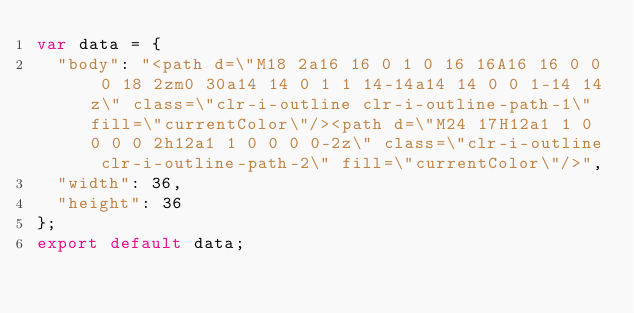Convert code to text. <code><loc_0><loc_0><loc_500><loc_500><_JavaScript_>var data = {
	"body": "<path d=\"M18 2a16 16 0 1 0 16 16A16 16 0 0 0 18 2zm0 30a14 14 0 1 1 14-14a14 14 0 0 1-14 14z\" class=\"clr-i-outline clr-i-outline-path-1\" fill=\"currentColor\"/><path d=\"M24 17H12a1 1 0 0 0 0 2h12a1 1 0 0 0 0-2z\" class=\"clr-i-outline clr-i-outline-path-2\" fill=\"currentColor\"/>",
	"width": 36,
	"height": 36
};
export default data;
</code> 